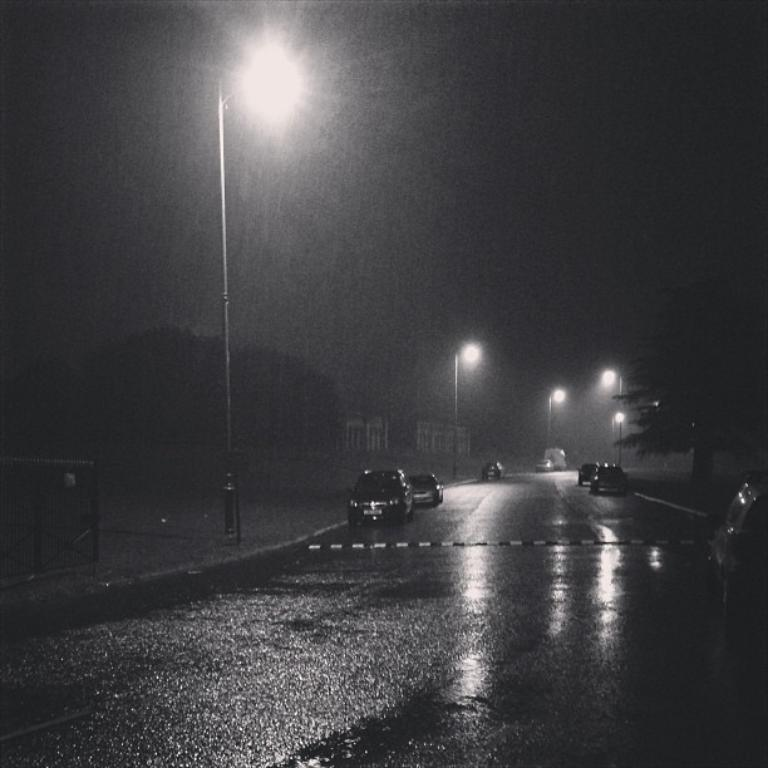What is the color scheme of the image? The image is black and white. What can be seen on the road in the image? There are vehicles on the road in the image. What type of lighting is present in the image? There are street lights in the image. What type of vegetation is present in the image? There are trees in the image. What type of barrier is present in the image? There is a fence in the image. What type of structure is present near the road in the image? There is a toll gate pole in the image. What type of man-made structure is present in the image? There is a wall in the image. How many rabbits can be seen in the image? There are no rabbits present in the image. 